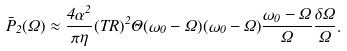Convert formula to latex. <formula><loc_0><loc_0><loc_500><loc_500>\bar { P } _ { 2 } ( \Omega ) \approx \frac { 4 \alpha ^ { 2 } } { \pi \eta } ( T R ) ^ { 2 } \Theta ( \omega _ { 0 } - \Omega ) ( \omega _ { 0 } - \Omega ) \frac { \omega _ { 0 } - \Omega } { \Omega } \frac { \delta \Omega } { \Omega } .</formula> 